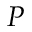Convert formula to latex. <formula><loc_0><loc_0><loc_500><loc_500>P</formula> 